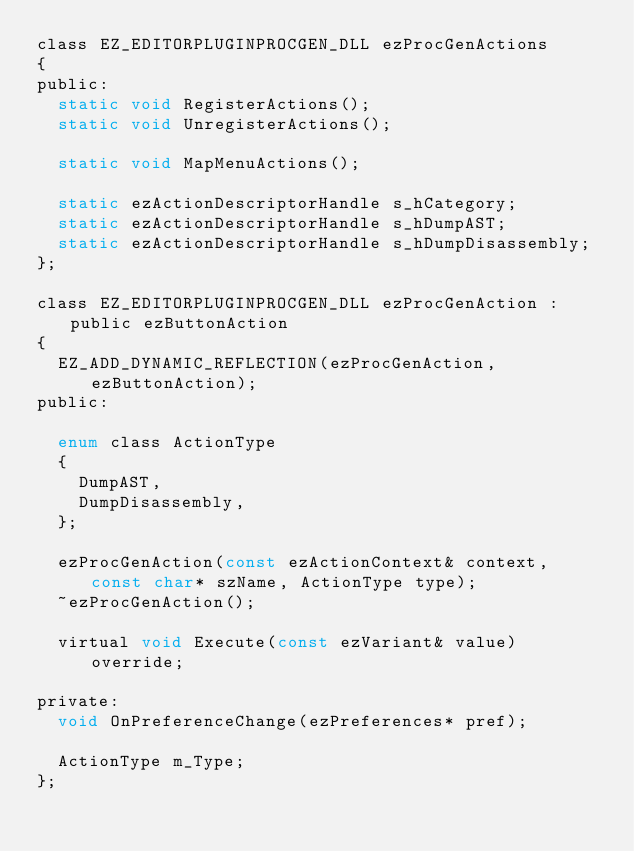Convert code to text. <code><loc_0><loc_0><loc_500><loc_500><_C_>class EZ_EDITORPLUGINPROCGEN_DLL ezProcGenActions
{
public:
  static void RegisterActions();
  static void UnregisterActions();

  static void MapMenuActions();

  static ezActionDescriptorHandle s_hCategory;
  static ezActionDescriptorHandle s_hDumpAST;
  static ezActionDescriptorHandle s_hDumpDisassembly;
};

class EZ_EDITORPLUGINPROCGEN_DLL ezProcGenAction : public ezButtonAction
{
  EZ_ADD_DYNAMIC_REFLECTION(ezProcGenAction, ezButtonAction);
public:

  enum class ActionType
  {
    DumpAST,
    DumpDisassembly,
  };

  ezProcGenAction(const ezActionContext& context, const char* szName, ActionType type);
  ~ezProcGenAction();

  virtual void Execute(const ezVariant& value) override;

private:
  void OnPreferenceChange(ezPreferences* pref);

  ActionType m_Type;
};
</code> 